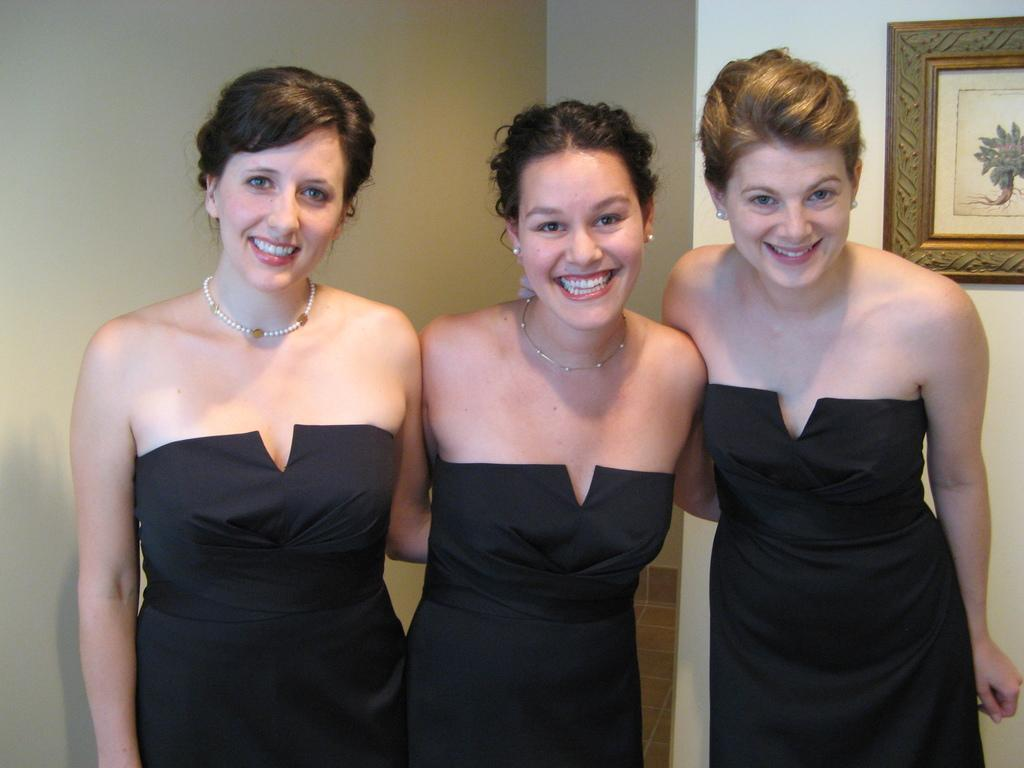What can be seen in the image? There are women standing in the image. Where are the women standing? The women are standing on the floor. What is visible in the background of the image? There is a wall and a photo frame in the background of the image. What type of bone is visible in the image? There is no bone present in the image. What kind of haircut do the women have in the image? The provided facts do not mention the women's haircuts, so it cannot be determined from the image. 